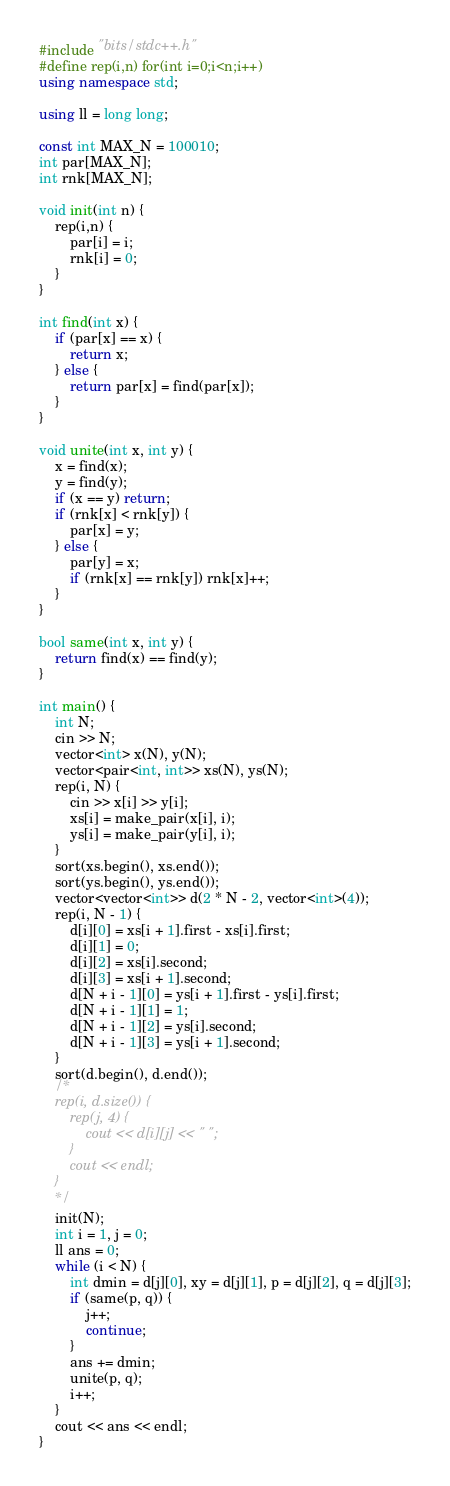<code> <loc_0><loc_0><loc_500><loc_500><_C++_>#include "bits/stdc++.h"
#define rep(i,n) for(int i=0;i<n;i++)
using namespace std;

using ll = long long;

const int MAX_N = 100010;
int par[MAX_N];
int rnk[MAX_N];

void init(int n) {
    rep(i,n) {
        par[i] = i;
        rnk[i] = 0;
    }
}

int find(int x) {
    if (par[x] == x) {
        return x;
    } else {
        return par[x] = find(par[x]);
    }
}

void unite(int x, int y) {
    x = find(x);
    y = find(y);
    if (x == y) return;
    if (rnk[x] < rnk[y]) {
        par[x] = y;
    } else {
        par[y] = x;
        if (rnk[x] == rnk[y]) rnk[x]++;
    }
}

bool same(int x, int y) {
    return find(x) == find(y);
}

int main() {
    int N;
    cin >> N;
    vector<int> x(N), y(N);
    vector<pair<int, int>> xs(N), ys(N);
    rep(i, N) {
        cin >> x[i] >> y[i];
        xs[i] = make_pair(x[i], i);
        ys[i] = make_pair(y[i], i);
    }
    sort(xs.begin(), xs.end());
    sort(ys.begin(), ys.end());
    vector<vector<int>> d(2 * N - 2, vector<int>(4));
    rep(i, N - 1) {
        d[i][0] = xs[i + 1].first - xs[i].first;
        d[i][1] = 0;
        d[i][2] = xs[i].second;
        d[i][3] = xs[i + 1].second;
        d[N + i - 1][0] = ys[i + 1].first - ys[i].first;
        d[N + i - 1][1] = 1;
        d[N + i - 1][2] = ys[i].second;
        d[N + i - 1][3] = ys[i + 1].second;
    }
    sort(d.begin(), d.end());
    /*
    rep(i, d.size()) {
        rep(j, 4) {
            cout << d[i][j] << " ";
        }
        cout << endl;
    }
    */
    init(N);
    int i = 1, j = 0;
    ll ans = 0;
    while (i < N) {
        int dmin = d[j][0], xy = d[j][1], p = d[j][2], q = d[j][3];
        if (same(p, q)) {
            j++;
            continue;
        }
        ans += dmin;
        unite(p, q);
        i++;
    }
    cout << ans << endl;
}</code> 